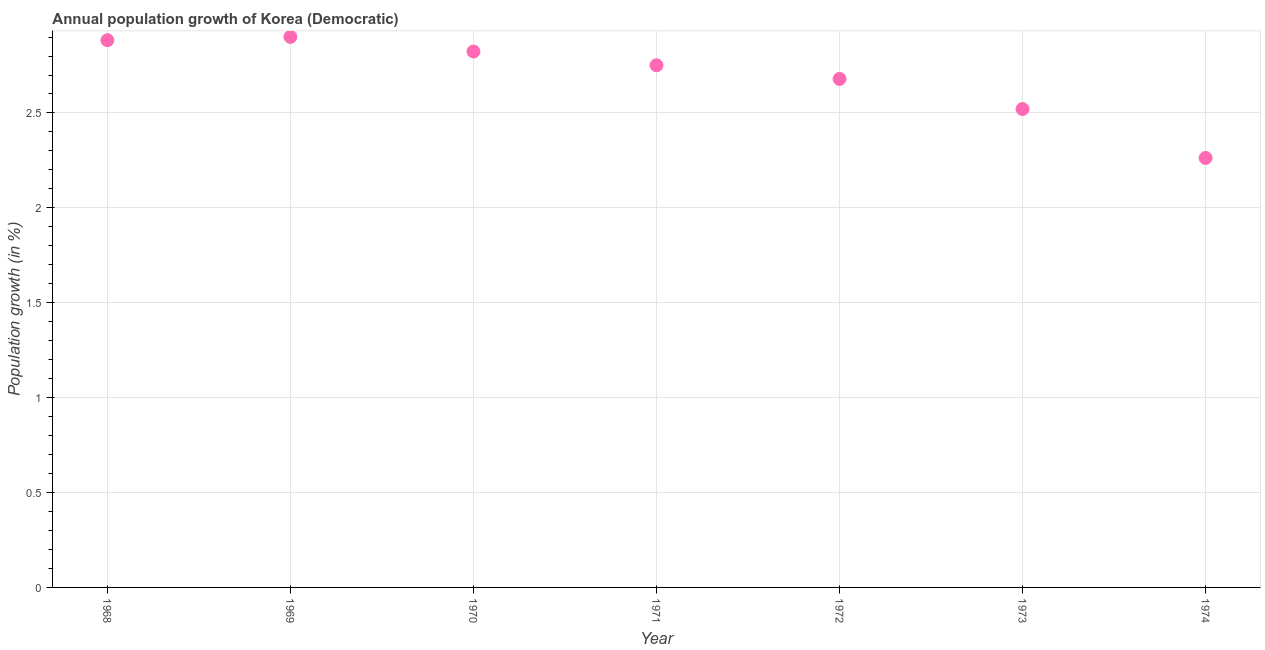What is the population growth in 1968?
Give a very brief answer. 2.88. Across all years, what is the maximum population growth?
Offer a very short reply. 2.9. Across all years, what is the minimum population growth?
Offer a very short reply. 2.26. In which year was the population growth maximum?
Provide a short and direct response. 1969. In which year was the population growth minimum?
Offer a very short reply. 1974. What is the sum of the population growth?
Make the answer very short. 18.82. What is the difference between the population growth in 1971 and 1973?
Your answer should be very brief. 0.23. What is the average population growth per year?
Keep it short and to the point. 2.69. What is the median population growth?
Keep it short and to the point. 2.75. Do a majority of the years between 1973 and 1972 (inclusive) have population growth greater than 1.5 %?
Offer a terse response. No. What is the ratio of the population growth in 1969 to that in 1974?
Keep it short and to the point. 1.28. Is the population growth in 1972 less than that in 1973?
Your response must be concise. No. Is the difference between the population growth in 1969 and 1974 greater than the difference between any two years?
Provide a succinct answer. Yes. What is the difference between the highest and the second highest population growth?
Ensure brevity in your answer.  0.02. What is the difference between the highest and the lowest population growth?
Ensure brevity in your answer.  0.64. In how many years, is the population growth greater than the average population growth taken over all years?
Provide a succinct answer. 4. How many dotlines are there?
Make the answer very short. 1. How many years are there in the graph?
Ensure brevity in your answer.  7. What is the title of the graph?
Your response must be concise. Annual population growth of Korea (Democratic). What is the label or title of the Y-axis?
Ensure brevity in your answer.  Population growth (in %). What is the Population growth (in %) in 1968?
Your answer should be compact. 2.88. What is the Population growth (in %) in 1969?
Offer a very short reply. 2.9. What is the Population growth (in %) in 1970?
Make the answer very short. 2.82. What is the Population growth (in %) in 1971?
Your answer should be compact. 2.75. What is the Population growth (in %) in 1972?
Offer a very short reply. 2.68. What is the Population growth (in %) in 1973?
Keep it short and to the point. 2.52. What is the Population growth (in %) in 1974?
Give a very brief answer. 2.26. What is the difference between the Population growth (in %) in 1968 and 1969?
Provide a succinct answer. -0.02. What is the difference between the Population growth (in %) in 1968 and 1970?
Provide a short and direct response. 0.06. What is the difference between the Population growth (in %) in 1968 and 1971?
Your answer should be very brief. 0.13. What is the difference between the Population growth (in %) in 1968 and 1972?
Provide a short and direct response. 0.2. What is the difference between the Population growth (in %) in 1968 and 1973?
Provide a succinct answer. 0.36. What is the difference between the Population growth (in %) in 1968 and 1974?
Your answer should be compact. 0.62. What is the difference between the Population growth (in %) in 1969 and 1970?
Your answer should be compact. 0.08. What is the difference between the Population growth (in %) in 1969 and 1971?
Offer a very short reply. 0.15. What is the difference between the Population growth (in %) in 1969 and 1972?
Make the answer very short. 0.22. What is the difference between the Population growth (in %) in 1969 and 1973?
Ensure brevity in your answer.  0.38. What is the difference between the Population growth (in %) in 1969 and 1974?
Make the answer very short. 0.64. What is the difference between the Population growth (in %) in 1970 and 1971?
Offer a terse response. 0.07. What is the difference between the Population growth (in %) in 1970 and 1972?
Keep it short and to the point. 0.14. What is the difference between the Population growth (in %) in 1970 and 1973?
Your answer should be compact. 0.3. What is the difference between the Population growth (in %) in 1970 and 1974?
Keep it short and to the point. 0.56. What is the difference between the Population growth (in %) in 1971 and 1972?
Your answer should be very brief. 0.07. What is the difference between the Population growth (in %) in 1971 and 1973?
Provide a succinct answer. 0.23. What is the difference between the Population growth (in %) in 1971 and 1974?
Ensure brevity in your answer.  0.49. What is the difference between the Population growth (in %) in 1972 and 1973?
Your answer should be very brief. 0.16. What is the difference between the Population growth (in %) in 1972 and 1974?
Your answer should be very brief. 0.42. What is the difference between the Population growth (in %) in 1973 and 1974?
Give a very brief answer. 0.26. What is the ratio of the Population growth (in %) in 1968 to that in 1971?
Provide a succinct answer. 1.05. What is the ratio of the Population growth (in %) in 1968 to that in 1972?
Provide a short and direct response. 1.08. What is the ratio of the Population growth (in %) in 1968 to that in 1973?
Ensure brevity in your answer.  1.14. What is the ratio of the Population growth (in %) in 1968 to that in 1974?
Your response must be concise. 1.27. What is the ratio of the Population growth (in %) in 1969 to that in 1970?
Give a very brief answer. 1.03. What is the ratio of the Population growth (in %) in 1969 to that in 1971?
Offer a very short reply. 1.05. What is the ratio of the Population growth (in %) in 1969 to that in 1972?
Your response must be concise. 1.08. What is the ratio of the Population growth (in %) in 1969 to that in 1973?
Your answer should be compact. 1.15. What is the ratio of the Population growth (in %) in 1969 to that in 1974?
Give a very brief answer. 1.28. What is the ratio of the Population growth (in %) in 1970 to that in 1972?
Offer a terse response. 1.05. What is the ratio of the Population growth (in %) in 1970 to that in 1973?
Keep it short and to the point. 1.12. What is the ratio of the Population growth (in %) in 1970 to that in 1974?
Offer a terse response. 1.25. What is the ratio of the Population growth (in %) in 1971 to that in 1973?
Offer a very short reply. 1.09. What is the ratio of the Population growth (in %) in 1971 to that in 1974?
Your answer should be very brief. 1.22. What is the ratio of the Population growth (in %) in 1972 to that in 1973?
Provide a succinct answer. 1.06. What is the ratio of the Population growth (in %) in 1972 to that in 1974?
Offer a very short reply. 1.18. What is the ratio of the Population growth (in %) in 1973 to that in 1974?
Keep it short and to the point. 1.11. 